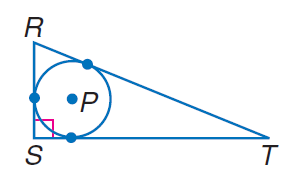Question: Find the perimeter of the polygon for the given information. S T = 18, radius of \odot P = 5.
Choices:
A. 58.5
B. 60
C. 70
D. 90
Answer with the letter. Answer: A 